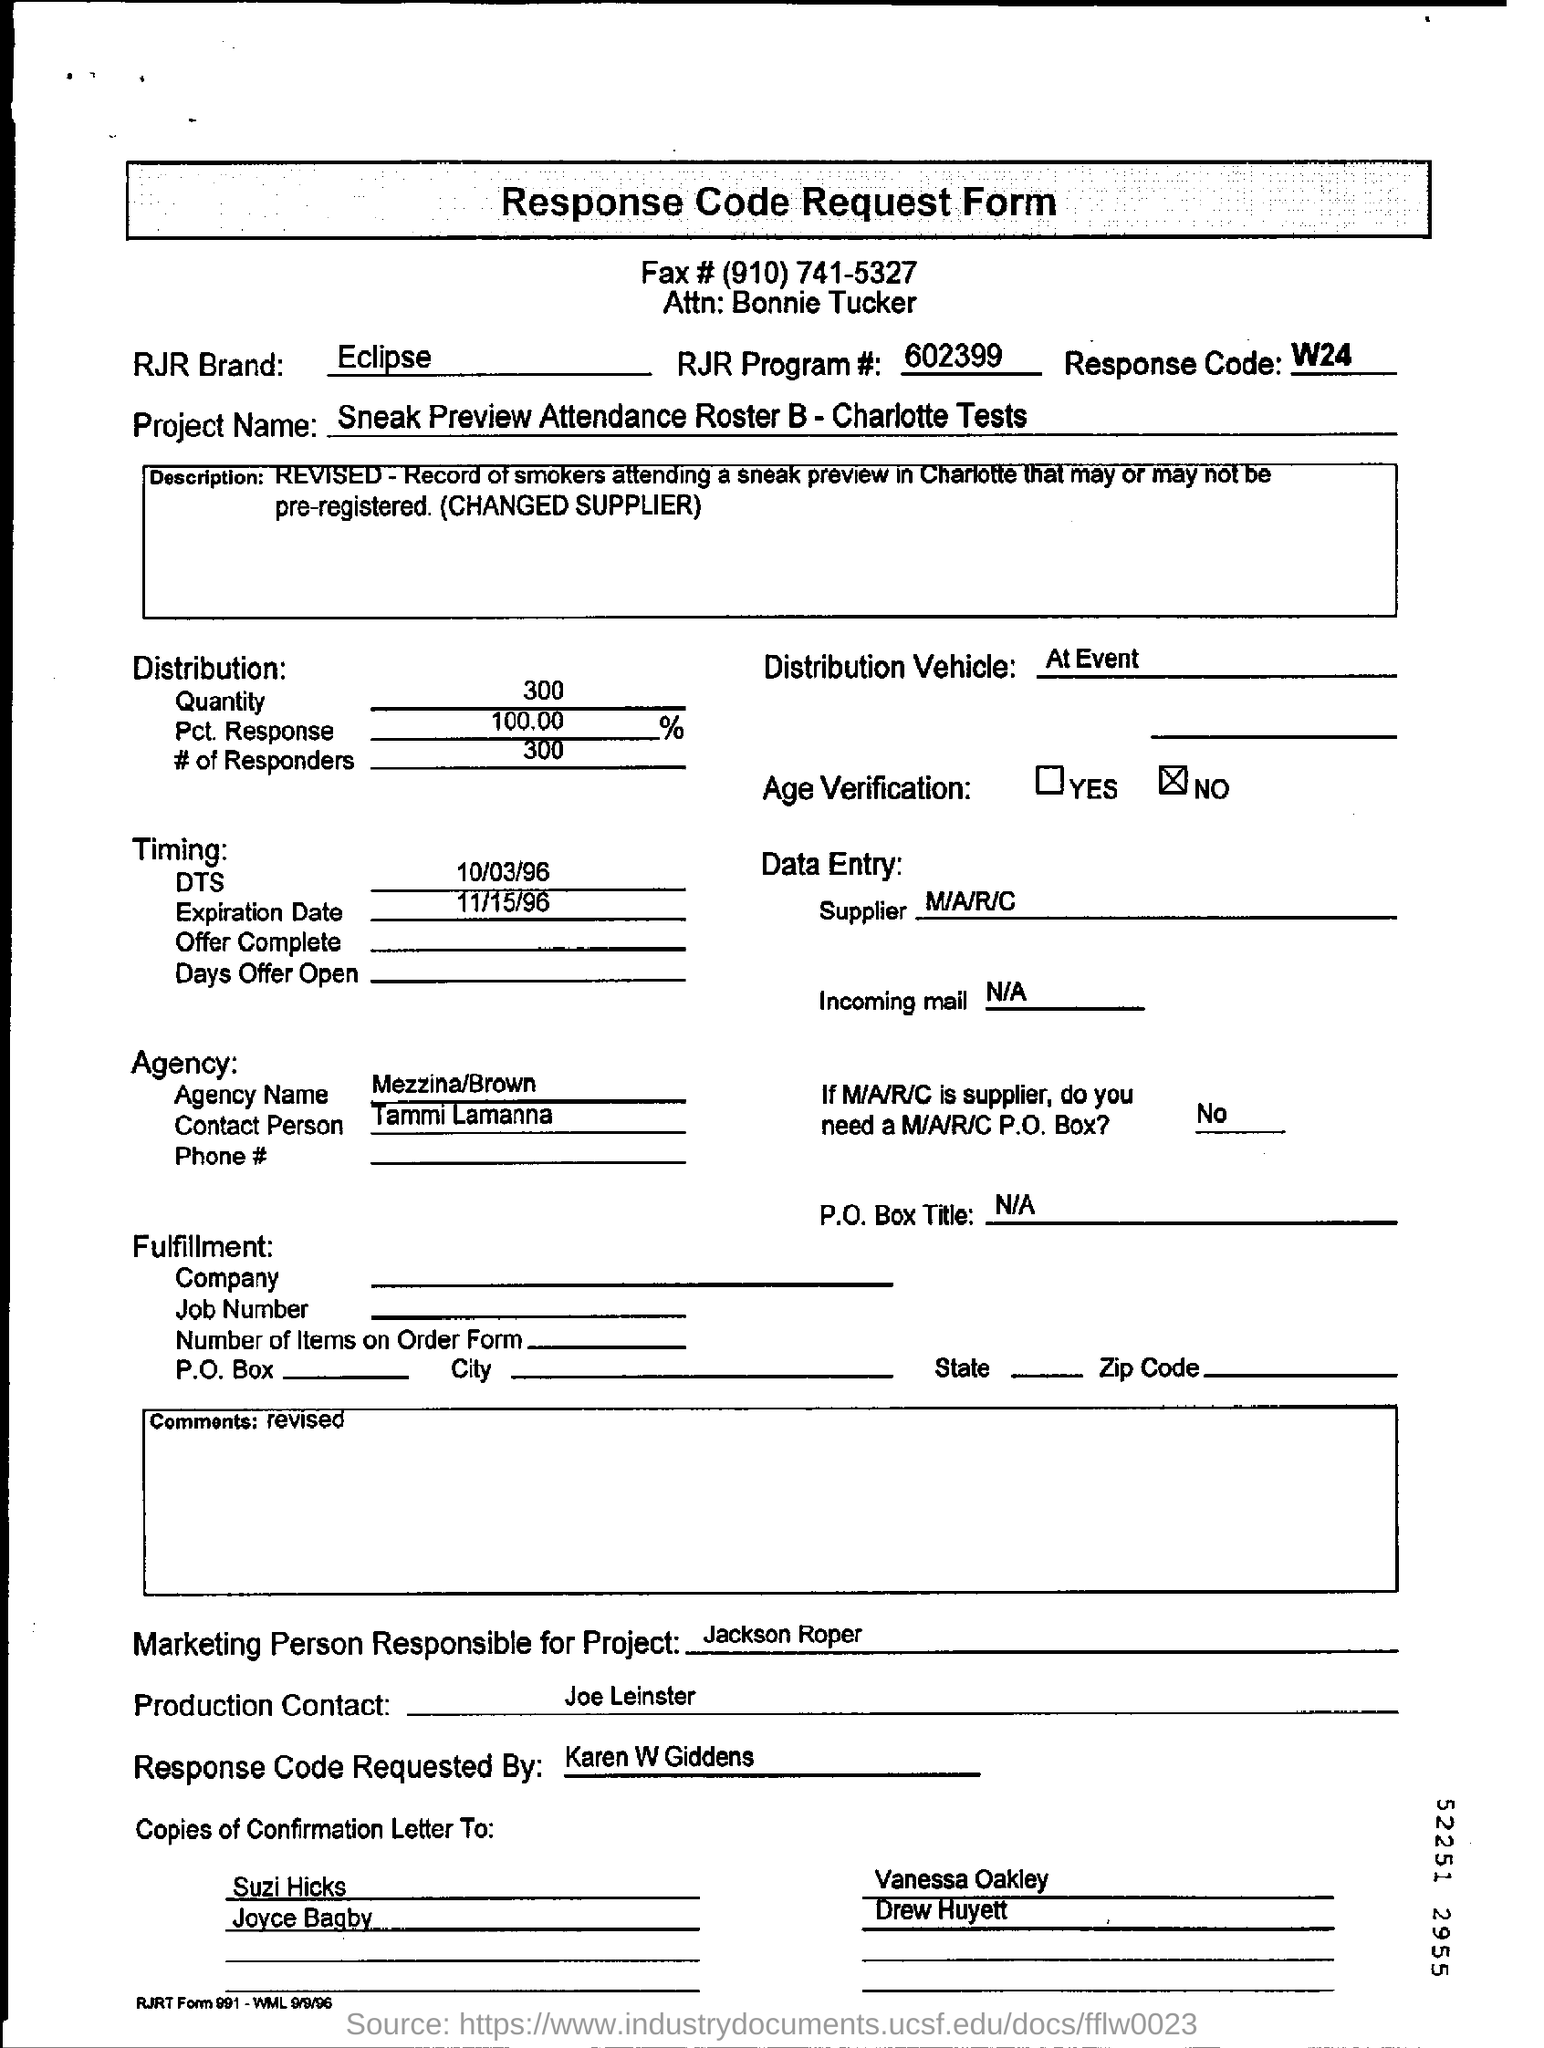Point out several critical features in this image. RJR brand Eclipse is mentioned in the text. The project name is Sneak Preview Attendance Roster B - Charlotte Tests. There were 300 responders. The individual who requested the response code is Karen W Giddens. 